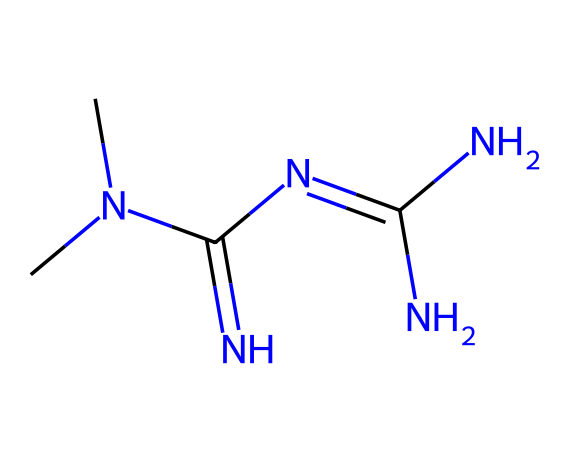What is the molecular formula of this chemical? By counting the number of carbon (C), hydrogen (H), nitrogen (N), and oxygen (O) atoms in the structure represented by the SMILES notation, we find the formula is C4H11N5.
Answer: C4H11N5 How many nitrogen atoms are present in this structure? The SMILES notation shows five nitrogen atoms connected in various ways within the structure.
Answer: 5 What type of molecule is represented by this chemical? This molecule is a biguanide, which is indicated by its structure containing two guanidine groups connecting through a carbon atom.
Answer: biguanide What is the primary action of metformin in diabetes management? Metformin primarily acts by decreasing hepatic glucose production and increasing insulin sensitivity, leading to reduced blood glucose levels.
Answer: decreases hepatic glucose production In which organ is metformin predominantly cleared from the body? Metformin is primarily excreted by the kidneys, and they play a crucial role in eliminating metformin from the bloodstream.
Answer: kidneys What role does metformin play in treating type 2 diabetes? The primary role of metformin is to improve blood glucose control by enhancing insulin action and reducing glucose production in the liver.
Answer: improves blood glucose control How does metformin affect glucose absorption in the intestines? Metformin decreases intestinal glucose absorption, impacting how much glucose enters circulation after meals, leading to lower blood glucose levels.
Answer: decreases intestinal glucose absorption 